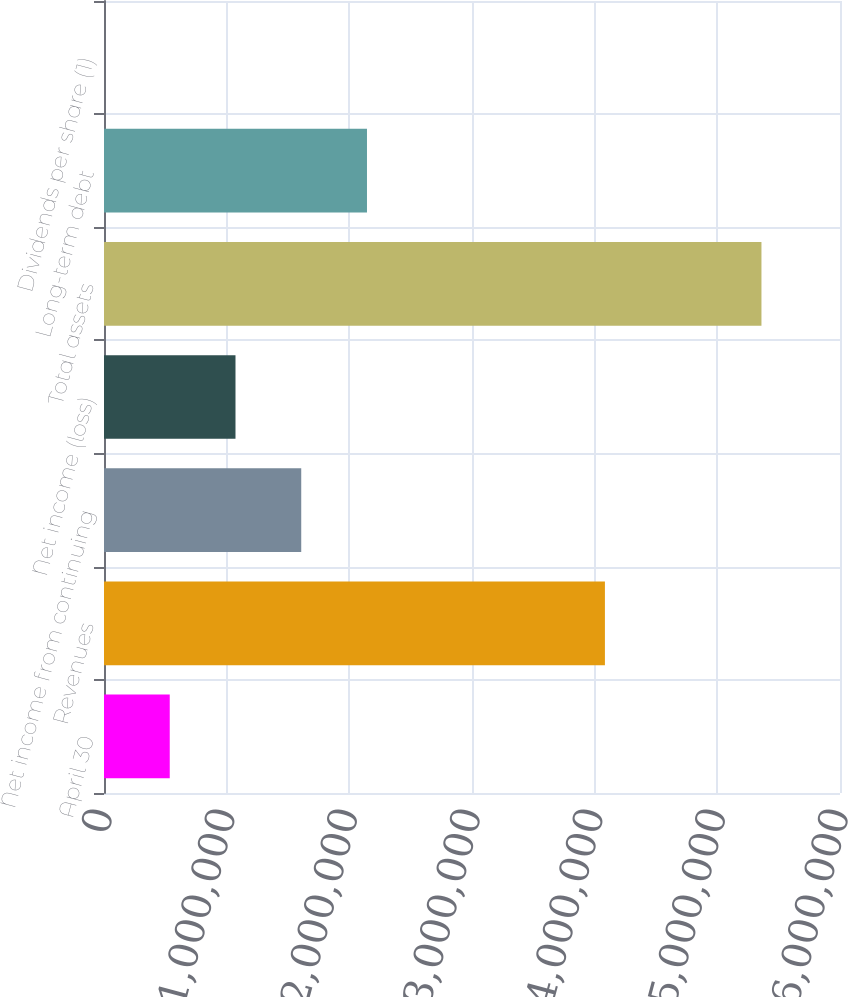Convert chart. <chart><loc_0><loc_0><loc_500><loc_500><bar_chart><fcel>April 30<fcel>Revenues<fcel>Net income from continuing<fcel>Net income (loss)<fcel>Total assets<fcel>Long-term debt<fcel>Dividends per share (1)<nl><fcel>535973<fcel>4.08358e+06<fcel>1.60792e+06<fcel>1.07194e+06<fcel>5.35972e+06<fcel>2.14389e+06<fcel>0.59<nl></chart> 